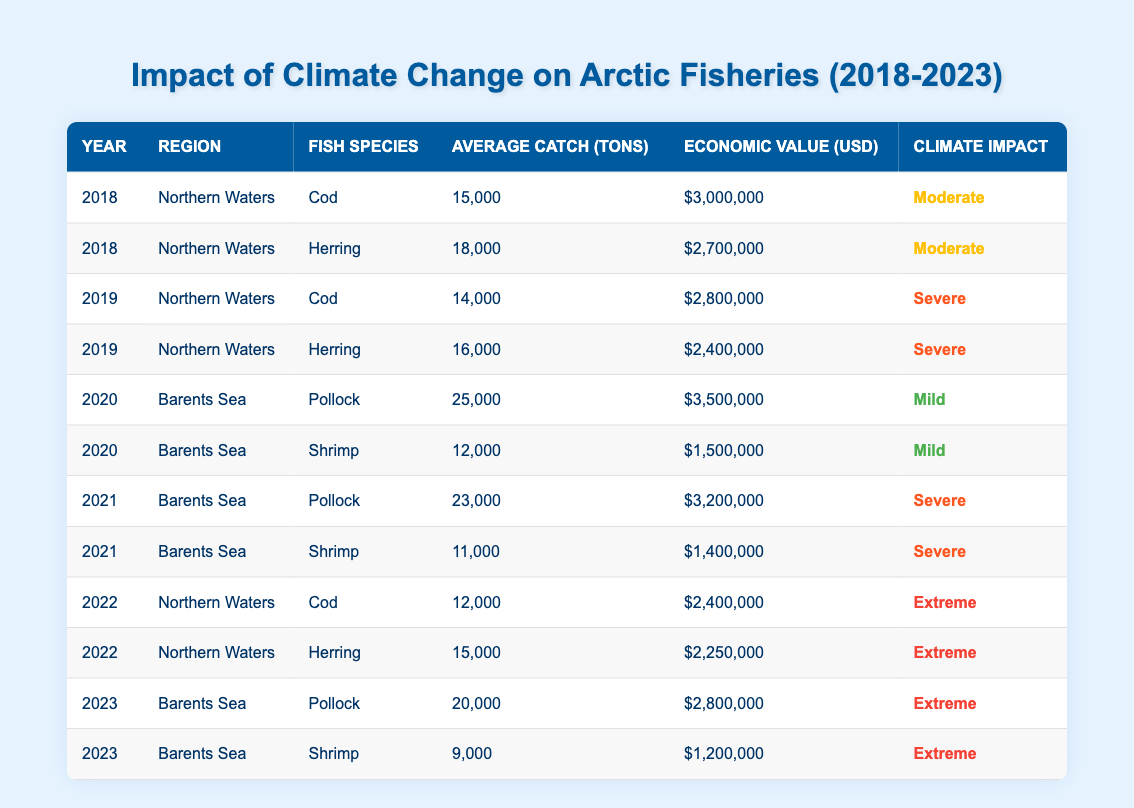What was the average catch of Cod in 2018? The table shows that in 2018, the average catch of Cod was 15,000 tons.
Answer: 15,000 tons What was the economic value of Herring in 2022? According to the table, the economic value of Herring in 2022 was $2,250,000.
Answer: $2,250,000 How much did the average catch of Pollock change from 2020 to 2021? In 2020, the average catch of Pollock was 25,000 tons, and in 2021, it dropped to 23,000 tons. The change is 25,000 - 23,000 = 2,000 tons.
Answer: 2,000 tons Is the climate impact factor for Shrimp in 2020 severe? The table indicates that the climate impact factor for Shrimp in 2020 was Mild, so the statement is false.
Answer: No What was the total economic value of Cod and Herring in the Northern Waters for 2019? In 2019, the economic value of Cod was $2,800,000 and for Herring was $2,400,000. Summing these gives $2,800,000 + $2,400,000 = $5,200,000.
Answer: $5,200,000 How did the average catch of Herring in Northern Waters change from 2018 to 2022? In 2018, the average catch of Herring was 18,000 tons, and in 2022, it decreased to 15,000 tons. The change is 18,000 - 15,000 = 3,000 tons.
Answer: Decreased by 3,000 tons Was the economic value of Shrimp in 2023 the lowest recorded in the table? The economic value of Shrimp in 2023 was $1,200,000, which is lower than the economic values in previous years (2020: $1,500,000; 2021: $1,400,000). So it is true that it's the lowest.
Answer: Yes What was the average climate impact factor for Cod from 2018 to 2022? The climate impact factors for Cod were Moderate (2018), Severe (2019), Extreme (2022). The average is categorized as Severe since it appears twice and Extreme once.
Answer: Severe By how much did the total economic value of fisheries in the Barents Sea increase from 2020 to 2023? For 2020, total economic value (Pollock: $3,500,000 + Shrimp: $1,500,000) = $5,000,000; for 2023, it is (Pollock: $2,800,000 + Shrimp: $1,200,000) = $4,000,000. The value decreased, so the difference is $5,000,000 - $4,000,000 = $1,000,000.
Answer: Decreased by $1,000,000 What percentage of the total catch in 2020 did Pollock represent in the Barents Sea? The total catch for Barents Sea in 2020 (Pollock: 25,000 tons + Shrimp: 12,000 tons) = 37,000 tons. Pollock's percentage = (25,000 / 37,000) * 100 ≈ 67.57%.
Answer: Approximately 67.57% 